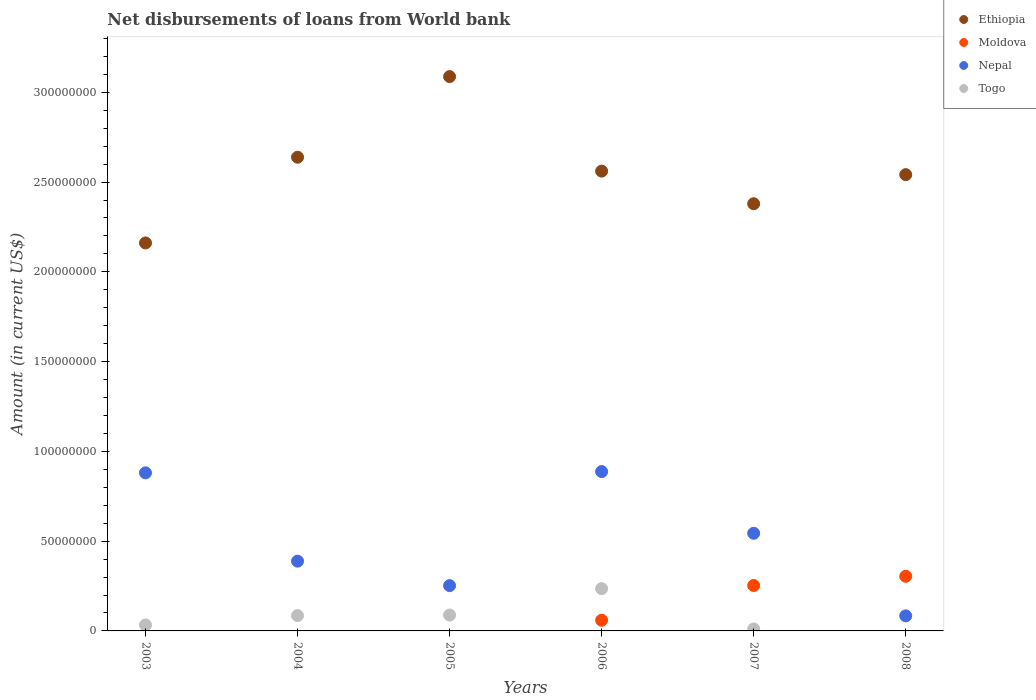How many different coloured dotlines are there?
Your answer should be compact. 4. Is the number of dotlines equal to the number of legend labels?
Provide a succinct answer. No. What is the amount of loan disbursed from World Bank in Nepal in 2004?
Offer a very short reply. 3.89e+07. Across all years, what is the maximum amount of loan disbursed from World Bank in Togo?
Make the answer very short. 2.35e+07. What is the total amount of loan disbursed from World Bank in Moldova in the graph?
Keep it short and to the point. 6.17e+07. What is the difference between the amount of loan disbursed from World Bank in Ethiopia in 2004 and that in 2005?
Provide a short and direct response. -4.49e+07. What is the difference between the amount of loan disbursed from World Bank in Ethiopia in 2006 and the amount of loan disbursed from World Bank in Togo in 2007?
Give a very brief answer. 2.55e+08. What is the average amount of loan disbursed from World Bank in Moldova per year?
Your response must be concise. 1.03e+07. In the year 2006, what is the difference between the amount of loan disbursed from World Bank in Moldova and amount of loan disbursed from World Bank in Togo?
Make the answer very short. -1.76e+07. What is the ratio of the amount of loan disbursed from World Bank in Nepal in 2007 to that in 2008?
Your answer should be very brief. 6.48. What is the difference between the highest and the second highest amount of loan disbursed from World Bank in Moldova?
Your response must be concise. 5.12e+06. What is the difference between the highest and the lowest amount of loan disbursed from World Bank in Nepal?
Provide a short and direct response. 8.04e+07. In how many years, is the amount of loan disbursed from World Bank in Togo greater than the average amount of loan disbursed from World Bank in Togo taken over all years?
Your answer should be compact. 3. Is the sum of the amount of loan disbursed from World Bank in Nepal in 2004 and 2006 greater than the maximum amount of loan disbursed from World Bank in Togo across all years?
Your answer should be compact. Yes. Is it the case that in every year, the sum of the amount of loan disbursed from World Bank in Ethiopia and amount of loan disbursed from World Bank in Moldova  is greater than the amount of loan disbursed from World Bank in Nepal?
Provide a short and direct response. Yes. Is the amount of loan disbursed from World Bank in Ethiopia strictly greater than the amount of loan disbursed from World Bank in Nepal over the years?
Make the answer very short. Yes. Where does the legend appear in the graph?
Your response must be concise. Top right. How many legend labels are there?
Your response must be concise. 4. How are the legend labels stacked?
Make the answer very short. Vertical. What is the title of the graph?
Provide a short and direct response. Net disbursements of loans from World bank. What is the label or title of the X-axis?
Make the answer very short. Years. What is the Amount (in current US$) in Ethiopia in 2003?
Make the answer very short. 2.16e+08. What is the Amount (in current US$) of Nepal in 2003?
Your answer should be very brief. 8.80e+07. What is the Amount (in current US$) in Togo in 2003?
Your response must be concise. 3.32e+06. What is the Amount (in current US$) in Ethiopia in 2004?
Offer a terse response. 2.64e+08. What is the Amount (in current US$) in Moldova in 2004?
Keep it short and to the point. 0. What is the Amount (in current US$) of Nepal in 2004?
Your response must be concise. 3.89e+07. What is the Amount (in current US$) of Togo in 2004?
Offer a terse response. 8.56e+06. What is the Amount (in current US$) in Ethiopia in 2005?
Provide a succinct answer. 3.09e+08. What is the Amount (in current US$) in Nepal in 2005?
Offer a terse response. 2.52e+07. What is the Amount (in current US$) in Togo in 2005?
Make the answer very short. 8.84e+06. What is the Amount (in current US$) of Ethiopia in 2006?
Ensure brevity in your answer.  2.56e+08. What is the Amount (in current US$) of Moldova in 2006?
Your answer should be very brief. 5.95e+06. What is the Amount (in current US$) of Nepal in 2006?
Give a very brief answer. 8.87e+07. What is the Amount (in current US$) in Togo in 2006?
Provide a short and direct response. 2.35e+07. What is the Amount (in current US$) in Ethiopia in 2007?
Make the answer very short. 2.38e+08. What is the Amount (in current US$) in Moldova in 2007?
Provide a short and direct response. 2.53e+07. What is the Amount (in current US$) of Nepal in 2007?
Provide a short and direct response. 5.44e+07. What is the Amount (in current US$) of Togo in 2007?
Your answer should be very brief. 1.07e+06. What is the Amount (in current US$) of Ethiopia in 2008?
Keep it short and to the point. 2.54e+08. What is the Amount (in current US$) of Moldova in 2008?
Give a very brief answer. 3.04e+07. What is the Amount (in current US$) in Nepal in 2008?
Your answer should be compact. 8.39e+06. What is the Amount (in current US$) in Togo in 2008?
Offer a very short reply. 0. Across all years, what is the maximum Amount (in current US$) of Ethiopia?
Your response must be concise. 3.09e+08. Across all years, what is the maximum Amount (in current US$) in Moldova?
Provide a succinct answer. 3.04e+07. Across all years, what is the maximum Amount (in current US$) of Nepal?
Provide a short and direct response. 8.87e+07. Across all years, what is the maximum Amount (in current US$) of Togo?
Give a very brief answer. 2.35e+07. Across all years, what is the minimum Amount (in current US$) of Ethiopia?
Offer a very short reply. 2.16e+08. Across all years, what is the minimum Amount (in current US$) in Nepal?
Your answer should be very brief. 8.39e+06. What is the total Amount (in current US$) of Ethiopia in the graph?
Keep it short and to the point. 1.54e+09. What is the total Amount (in current US$) in Moldova in the graph?
Provide a succinct answer. 6.17e+07. What is the total Amount (in current US$) in Nepal in the graph?
Give a very brief answer. 3.04e+08. What is the total Amount (in current US$) in Togo in the graph?
Your response must be concise. 4.53e+07. What is the difference between the Amount (in current US$) of Ethiopia in 2003 and that in 2004?
Provide a short and direct response. -4.77e+07. What is the difference between the Amount (in current US$) in Nepal in 2003 and that in 2004?
Your answer should be very brief. 4.92e+07. What is the difference between the Amount (in current US$) in Togo in 2003 and that in 2004?
Your answer should be compact. -5.24e+06. What is the difference between the Amount (in current US$) of Ethiopia in 2003 and that in 2005?
Provide a succinct answer. -9.26e+07. What is the difference between the Amount (in current US$) of Nepal in 2003 and that in 2005?
Offer a very short reply. 6.28e+07. What is the difference between the Amount (in current US$) of Togo in 2003 and that in 2005?
Your answer should be very brief. -5.52e+06. What is the difference between the Amount (in current US$) of Ethiopia in 2003 and that in 2006?
Your answer should be very brief. -4.00e+07. What is the difference between the Amount (in current US$) in Nepal in 2003 and that in 2006?
Your answer should be compact. -6.98e+05. What is the difference between the Amount (in current US$) in Togo in 2003 and that in 2006?
Provide a short and direct response. -2.02e+07. What is the difference between the Amount (in current US$) of Ethiopia in 2003 and that in 2007?
Make the answer very short. -2.18e+07. What is the difference between the Amount (in current US$) of Nepal in 2003 and that in 2007?
Your response must be concise. 3.37e+07. What is the difference between the Amount (in current US$) in Togo in 2003 and that in 2007?
Your answer should be compact. 2.25e+06. What is the difference between the Amount (in current US$) of Ethiopia in 2003 and that in 2008?
Make the answer very short. -3.80e+07. What is the difference between the Amount (in current US$) in Nepal in 2003 and that in 2008?
Your response must be concise. 7.97e+07. What is the difference between the Amount (in current US$) of Ethiopia in 2004 and that in 2005?
Your answer should be compact. -4.49e+07. What is the difference between the Amount (in current US$) of Nepal in 2004 and that in 2005?
Give a very brief answer. 1.36e+07. What is the difference between the Amount (in current US$) of Togo in 2004 and that in 2005?
Give a very brief answer. -2.81e+05. What is the difference between the Amount (in current US$) in Ethiopia in 2004 and that in 2006?
Offer a very short reply. 7.74e+06. What is the difference between the Amount (in current US$) of Nepal in 2004 and that in 2006?
Give a very brief answer. -4.99e+07. What is the difference between the Amount (in current US$) in Togo in 2004 and that in 2006?
Your response must be concise. -1.50e+07. What is the difference between the Amount (in current US$) of Ethiopia in 2004 and that in 2007?
Provide a succinct answer. 2.59e+07. What is the difference between the Amount (in current US$) in Nepal in 2004 and that in 2007?
Give a very brief answer. -1.55e+07. What is the difference between the Amount (in current US$) in Togo in 2004 and that in 2007?
Make the answer very short. 7.49e+06. What is the difference between the Amount (in current US$) of Ethiopia in 2004 and that in 2008?
Your response must be concise. 9.70e+06. What is the difference between the Amount (in current US$) of Nepal in 2004 and that in 2008?
Ensure brevity in your answer.  3.05e+07. What is the difference between the Amount (in current US$) in Ethiopia in 2005 and that in 2006?
Provide a short and direct response. 5.26e+07. What is the difference between the Amount (in current US$) in Nepal in 2005 and that in 2006?
Provide a short and direct response. -6.35e+07. What is the difference between the Amount (in current US$) of Togo in 2005 and that in 2006?
Your response must be concise. -1.47e+07. What is the difference between the Amount (in current US$) in Ethiopia in 2005 and that in 2007?
Offer a very short reply. 7.08e+07. What is the difference between the Amount (in current US$) of Nepal in 2005 and that in 2007?
Offer a terse response. -2.92e+07. What is the difference between the Amount (in current US$) of Togo in 2005 and that in 2007?
Provide a short and direct response. 7.77e+06. What is the difference between the Amount (in current US$) of Ethiopia in 2005 and that in 2008?
Offer a terse response. 5.46e+07. What is the difference between the Amount (in current US$) in Nepal in 2005 and that in 2008?
Offer a terse response. 1.68e+07. What is the difference between the Amount (in current US$) of Ethiopia in 2006 and that in 2007?
Offer a terse response. 1.82e+07. What is the difference between the Amount (in current US$) of Moldova in 2006 and that in 2007?
Keep it short and to the point. -1.94e+07. What is the difference between the Amount (in current US$) of Nepal in 2006 and that in 2007?
Provide a short and direct response. 3.44e+07. What is the difference between the Amount (in current US$) in Togo in 2006 and that in 2007?
Offer a terse response. 2.25e+07. What is the difference between the Amount (in current US$) of Ethiopia in 2006 and that in 2008?
Keep it short and to the point. 1.96e+06. What is the difference between the Amount (in current US$) of Moldova in 2006 and that in 2008?
Offer a terse response. -2.45e+07. What is the difference between the Amount (in current US$) in Nepal in 2006 and that in 2008?
Provide a succinct answer. 8.04e+07. What is the difference between the Amount (in current US$) in Ethiopia in 2007 and that in 2008?
Ensure brevity in your answer.  -1.62e+07. What is the difference between the Amount (in current US$) of Moldova in 2007 and that in 2008?
Keep it short and to the point. -5.12e+06. What is the difference between the Amount (in current US$) of Nepal in 2007 and that in 2008?
Offer a terse response. 4.60e+07. What is the difference between the Amount (in current US$) of Ethiopia in 2003 and the Amount (in current US$) of Nepal in 2004?
Your answer should be very brief. 1.77e+08. What is the difference between the Amount (in current US$) of Ethiopia in 2003 and the Amount (in current US$) of Togo in 2004?
Offer a terse response. 2.08e+08. What is the difference between the Amount (in current US$) in Nepal in 2003 and the Amount (in current US$) in Togo in 2004?
Offer a terse response. 7.95e+07. What is the difference between the Amount (in current US$) in Ethiopia in 2003 and the Amount (in current US$) in Nepal in 2005?
Your answer should be very brief. 1.91e+08. What is the difference between the Amount (in current US$) in Ethiopia in 2003 and the Amount (in current US$) in Togo in 2005?
Make the answer very short. 2.07e+08. What is the difference between the Amount (in current US$) of Nepal in 2003 and the Amount (in current US$) of Togo in 2005?
Offer a terse response. 7.92e+07. What is the difference between the Amount (in current US$) of Ethiopia in 2003 and the Amount (in current US$) of Moldova in 2006?
Your answer should be very brief. 2.10e+08. What is the difference between the Amount (in current US$) of Ethiopia in 2003 and the Amount (in current US$) of Nepal in 2006?
Make the answer very short. 1.27e+08. What is the difference between the Amount (in current US$) in Ethiopia in 2003 and the Amount (in current US$) in Togo in 2006?
Provide a succinct answer. 1.93e+08. What is the difference between the Amount (in current US$) in Nepal in 2003 and the Amount (in current US$) in Togo in 2006?
Ensure brevity in your answer.  6.45e+07. What is the difference between the Amount (in current US$) of Ethiopia in 2003 and the Amount (in current US$) of Moldova in 2007?
Your answer should be compact. 1.91e+08. What is the difference between the Amount (in current US$) in Ethiopia in 2003 and the Amount (in current US$) in Nepal in 2007?
Your answer should be compact. 1.62e+08. What is the difference between the Amount (in current US$) in Ethiopia in 2003 and the Amount (in current US$) in Togo in 2007?
Your response must be concise. 2.15e+08. What is the difference between the Amount (in current US$) of Nepal in 2003 and the Amount (in current US$) of Togo in 2007?
Your answer should be very brief. 8.70e+07. What is the difference between the Amount (in current US$) of Ethiopia in 2003 and the Amount (in current US$) of Moldova in 2008?
Ensure brevity in your answer.  1.86e+08. What is the difference between the Amount (in current US$) in Ethiopia in 2003 and the Amount (in current US$) in Nepal in 2008?
Offer a terse response. 2.08e+08. What is the difference between the Amount (in current US$) of Ethiopia in 2004 and the Amount (in current US$) of Nepal in 2005?
Provide a succinct answer. 2.39e+08. What is the difference between the Amount (in current US$) in Ethiopia in 2004 and the Amount (in current US$) in Togo in 2005?
Your response must be concise. 2.55e+08. What is the difference between the Amount (in current US$) of Nepal in 2004 and the Amount (in current US$) of Togo in 2005?
Make the answer very short. 3.00e+07. What is the difference between the Amount (in current US$) of Ethiopia in 2004 and the Amount (in current US$) of Moldova in 2006?
Offer a terse response. 2.58e+08. What is the difference between the Amount (in current US$) of Ethiopia in 2004 and the Amount (in current US$) of Nepal in 2006?
Keep it short and to the point. 1.75e+08. What is the difference between the Amount (in current US$) of Ethiopia in 2004 and the Amount (in current US$) of Togo in 2006?
Ensure brevity in your answer.  2.40e+08. What is the difference between the Amount (in current US$) in Nepal in 2004 and the Amount (in current US$) in Togo in 2006?
Offer a terse response. 1.53e+07. What is the difference between the Amount (in current US$) of Ethiopia in 2004 and the Amount (in current US$) of Moldova in 2007?
Offer a terse response. 2.39e+08. What is the difference between the Amount (in current US$) of Ethiopia in 2004 and the Amount (in current US$) of Nepal in 2007?
Give a very brief answer. 2.09e+08. What is the difference between the Amount (in current US$) of Ethiopia in 2004 and the Amount (in current US$) of Togo in 2007?
Provide a short and direct response. 2.63e+08. What is the difference between the Amount (in current US$) in Nepal in 2004 and the Amount (in current US$) in Togo in 2007?
Provide a short and direct response. 3.78e+07. What is the difference between the Amount (in current US$) of Ethiopia in 2004 and the Amount (in current US$) of Moldova in 2008?
Keep it short and to the point. 2.33e+08. What is the difference between the Amount (in current US$) of Ethiopia in 2004 and the Amount (in current US$) of Nepal in 2008?
Provide a short and direct response. 2.55e+08. What is the difference between the Amount (in current US$) of Ethiopia in 2005 and the Amount (in current US$) of Moldova in 2006?
Offer a terse response. 3.03e+08. What is the difference between the Amount (in current US$) of Ethiopia in 2005 and the Amount (in current US$) of Nepal in 2006?
Give a very brief answer. 2.20e+08. What is the difference between the Amount (in current US$) of Ethiopia in 2005 and the Amount (in current US$) of Togo in 2006?
Ensure brevity in your answer.  2.85e+08. What is the difference between the Amount (in current US$) of Nepal in 2005 and the Amount (in current US$) of Togo in 2006?
Offer a very short reply. 1.69e+06. What is the difference between the Amount (in current US$) of Ethiopia in 2005 and the Amount (in current US$) of Moldova in 2007?
Make the answer very short. 2.83e+08. What is the difference between the Amount (in current US$) in Ethiopia in 2005 and the Amount (in current US$) in Nepal in 2007?
Provide a short and direct response. 2.54e+08. What is the difference between the Amount (in current US$) of Ethiopia in 2005 and the Amount (in current US$) of Togo in 2007?
Ensure brevity in your answer.  3.08e+08. What is the difference between the Amount (in current US$) of Nepal in 2005 and the Amount (in current US$) of Togo in 2007?
Your response must be concise. 2.42e+07. What is the difference between the Amount (in current US$) in Ethiopia in 2005 and the Amount (in current US$) in Moldova in 2008?
Provide a short and direct response. 2.78e+08. What is the difference between the Amount (in current US$) in Ethiopia in 2005 and the Amount (in current US$) in Nepal in 2008?
Ensure brevity in your answer.  3.00e+08. What is the difference between the Amount (in current US$) of Ethiopia in 2006 and the Amount (in current US$) of Moldova in 2007?
Ensure brevity in your answer.  2.31e+08. What is the difference between the Amount (in current US$) of Ethiopia in 2006 and the Amount (in current US$) of Nepal in 2007?
Your answer should be very brief. 2.02e+08. What is the difference between the Amount (in current US$) of Ethiopia in 2006 and the Amount (in current US$) of Togo in 2007?
Provide a short and direct response. 2.55e+08. What is the difference between the Amount (in current US$) of Moldova in 2006 and the Amount (in current US$) of Nepal in 2007?
Give a very brief answer. -4.84e+07. What is the difference between the Amount (in current US$) in Moldova in 2006 and the Amount (in current US$) in Togo in 2007?
Offer a terse response. 4.88e+06. What is the difference between the Amount (in current US$) in Nepal in 2006 and the Amount (in current US$) in Togo in 2007?
Give a very brief answer. 8.77e+07. What is the difference between the Amount (in current US$) in Ethiopia in 2006 and the Amount (in current US$) in Moldova in 2008?
Your answer should be very brief. 2.26e+08. What is the difference between the Amount (in current US$) of Ethiopia in 2006 and the Amount (in current US$) of Nepal in 2008?
Keep it short and to the point. 2.48e+08. What is the difference between the Amount (in current US$) in Moldova in 2006 and the Amount (in current US$) in Nepal in 2008?
Keep it short and to the point. -2.44e+06. What is the difference between the Amount (in current US$) in Ethiopia in 2007 and the Amount (in current US$) in Moldova in 2008?
Provide a short and direct response. 2.07e+08. What is the difference between the Amount (in current US$) in Ethiopia in 2007 and the Amount (in current US$) in Nepal in 2008?
Your answer should be very brief. 2.30e+08. What is the difference between the Amount (in current US$) in Moldova in 2007 and the Amount (in current US$) in Nepal in 2008?
Ensure brevity in your answer.  1.69e+07. What is the average Amount (in current US$) of Ethiopia per year?
Your response must be concise. 2.56e+08. What is the average Amount (in current US$) in Moldova per year?
Keep it short and to the point. 1.03e+07. What is the average Amount (in current US$) of Nepal per year?
Make the answer very short. 5.06e+07. What is the average Amount (in current US$) of Togo per year?
Your response must be concise. 7.56e+06. In the year 2003, what is the difference between the Amount (in current US$) in Ethiopia and Amount (in current US$) in Nepal?
Ensure brevity in your answer.  1.28e+08. In the year 2003, what is the difference between the Amount (in current US$) of Ethiopia and Amount (in current US$) of Togo?
Keep it short and to the point. 2.13e+08. In the year 2003, what is the difference between the Amount (in current US$) of Nepal and Amount (in current US$) of Togo?
Make the answer very short. 8.47e+07. In the year 2004, what is the difference between the Amount (in current US$) of Ethiopia and Amount (in current US$) of Nepal?
Offer a very short reply. 2.25e+08. In the year 2004, what is the difference between the Amount (in current US$) in Ethiopia and Amount (in current US$) in Togo?
Keep it short and to the point. 2.55e+08. In the year 2004, what is the difference between the Amount (in current US$) in Nepal and Amount (in current US$) in Togo?
Give a very brief answer. 3.03e+07. In the year 2005, what is the difference between the Amount (in current US$) of Ethiopia and Amount (in current US$) of Nepal?
Ensure brevity in your answer.  2.84e+08. In the year 2005, what is the difference between the Amount (in current US$) in Ethiopia and Amount (in current US$) in Togo?
Keep it short and to the point. 3.00e+08. In the year 2005, what is the difference between the Amount (in current US$) in Nepal and Amount (in current US$) in Togo?
Ensure brevity in your answer.  1.64e+07. In the year 2006, what is the difference between the Amount (in current US$) in Ethiopia and Amount (in current US$) in Moldova?
Offer a very short reply. 2.50e+08. In the year 2006, what is the difference between the Amount (in current US$) of Ethiopia and Amount (in current US$) of Nepal?
Your answer should be compact. 1.67e+08. In the year 2006, what is the difference between the Amount (in current US$) of Ethiopia and Amount (in current US$) of Togo?
Keep it short and to the point. 2.33e+08. In the year 2006, what is the difference between the Amount (in current US$) in Moldova and Amount (in current US$) in Nepal?
Keep it short and to the point. -8.28e+07. In the year 2006, what is the difference between the Amount (in current US$) in Moldova and Amount (in current US$) in Togo?
Provide a succinct answer. -1.76e+07. In the year 2006, what is the difference between the Amount (in current US$) of Nepal and Amount (in current US$) of Togo?
Give a very brief answer. 6.52e+07. In the year 2007, what is the difference between the Amount (in current US$) in Ethiopia and Amount (in current US$) in Moldova?
Provide a short and direct response. 2.13e+08. In the year 2007, what is the difference between the Amount (in current US$) of Ethiopia and Amount (in current US$) of Nepal?
Make the answer very short. 1.84e+08. In the year 2007, what is the difference between the Amount (in current US$) of Ethiopia and Amount (in current US$) of Togo?
Your answer should be compact. 2.37e+08. In the year 2007, what is the difference between the Amount (in current US$) of Moldova and Amount (in current US$) of Nepal?
Keep it short and to the point. -2.91e+07. In the year 2007, what is the difference between the Amount (in current US$) in Moldova and Amount (in current US$) in Togo?
Your answer should be compact. 2.42e+07. In the year 2007, what is the difference between the Amount (in current US$) in Nepal and Amount (in current US$) in Togo?
Your answer should be very brief. 5.33e+07. In the year 2008, what is the difference between the Amount (in current US$) in Ethiopia and Amount (in current US$) in Moldova?
Provide a short and direct response. 2.24e+08. In the year 2008, what is the difference between the Amount (in current US$) in Ethiopia and Amount (in current US$) in Nepal?
Provide a succinct answer. 2.46e+08. In the year 2008, what is the difference between the Amount (in current US$) of Moldova and Amount (in current US$) of Nepal?
Provide a short and direct response. 2.20e+07. What is the ratio of the Amount (in current US$) of Ethiopia in 2003 to that in 2004?
Offer a terse response. 0.82. What is the ratio of the Amount (in current US$) of Nepal in 2003 to that in 2004?
Your answer should be very brief. 2.27. What is the ratio of the Amount (in current US$) of Togo in 2003 to that in 2004?
Provide a short and direct response. 0.39. What is the ratio of the Amount (in current US$) in Ethiopia in 2003 to that in 2005?
Provide a succinct answer. 0.7. What is the ratio of the Amount (in current US$) in Nepal in 2003 to that in 2005?
Make the answer very short. 3.49. What is the ratio of the Amount (in current US$) of Togo in 2003 to that in 2005?
Make the answer very short. 0.38. What is the ratio of the Amount (in current US$) of Ethiopia in 2003 to that in 2006?
Offer a terse response. 0.84. What is the ratio of the Amount (in current US$) in Togo in 2003 to that in 2006?
Your response must be concise. 0.14. What is the ratio of the Amount (in current US$) in Ethiopia in 2003 to that in 2007?
Make the answer very short. 0.91. What is the ratio of the Amount (in current US$) in Nepal in 2003 to that in 2007?
Provide a short and direct response. 1.62. What is the ratio of the Amount (in current US$) in Togo in 2003 to that in 2007?
Give a very brief answer. 3.09. What is the ratio of the Amount (in current US$) in Ethiopia in 2003 to that in 2008?
Give a very brief answer. 0.85. What is the ratio of the Amount (in current US$) of Nepal in 2003 to that in 2008?
Provide a short and direct response. 10.49. What is the ratio of the Amount (in current US$) of Ethiopia in 2004 to that in 2005?
Your answer should be compact. 0.85. What is the ratio of the Amount (in current US$) in Nepal in 2004 to that in 2005?
Your response must be concise. 1.54. What is the ratio of the Amount (in current US$) in Togo in 2004 to that in 2005?
Provide a short and direct response. 0.97. What is the ratio of the Amount (in current US$) in Ethiopia in 2004 to that in 2006?
Ensure brevity in your answer.  1.03. What is the ratio of the Amount (in current US$) of Nepal in 2004 to that in 2006?
Provide a succinct answer. 0.44. What is the ratio of the Amount (in current US$) in Togo in 2004 to that in 2006?
Provide a succinct answer. 0.36. What is the ratio of the Amount (in current US$) in Ethiopia in 2004 to that in 2007?
Your answer should be very brief. 1.11. What is the ratio of the Amount (in current US$) of Nepal in 2004 to that in 2007?
Provide a short and direct response. 0.71. What is the ratio of the Amount (in current US$) of Togo in 2004 to that in 2007?
Make the answer very short. 7.98. What is the ratio of the Amount (in current US$) of Ethiopia in 2004 to that in 2008?
Offer a terse response. 1.04. What is the ratio of the Amount (in current US$) in Nepal in 2004 to that in 2008?
Your response must be concise. 4.63. What is the ratio of the Amount (in current US$) in Ethiopia in 2005 to that in 2006?
Your answer should be compact. 1.21. What is the ratio of the Amount (in current US$) in Nepal in 2005 to that in 2006?
Offer a very short reply. 0.28. What is the ratio of the Amount (in current US$) of Togo in 2005 to that in 2006?
Ensure brevity in your answer.  0.38. What is the ratio of the Amount (in current US$) in Ethiopia in 2005 to that in 2007?
Provide a short and direct response. 1.3. What is the ratio of the Amount (in current US$) of Nepal in 2005 to that in 2007?
Your answer should be compact. 0.46. What is the ratio of the Amount (in current US$) of Togo in 2005 to that in 2007?
Keep it short and to the point. 8.24. What is the ratio of the Amount (in current US$) in Ethiopia in 2005 to that in 2008?
Keep it short and to the point. 1.21. What is the ratio of the Amount (in current US$) of Nepal in 2005 to that in 2008?
Make the answer very short. 3.01. What is the ratio of the Amount (in current US$) of Ethiopia in 2006 to that in 2007?
Your response must be concise. 1.08. What is the ratio of the Amount (in current US$) in Moldova in 2006 to that in 2007?
Make the answer very short. 0.24. What is the ratio of the Amount (in current US$) in Nepal in 2006 to that in 2007?
Your response must be concise. 1.63. What is the ratio of the Amount (in current US$) in Togo in 2006 to that in 2007?
Give a very brief answer. 21.94. What is the ratio of the Amount (in current US$) in Ethiopia in 2006 to that in 2008?
Your response must be concise. 1.01. What is the ratio of the Amount (in current US$) in Moldova in 2006 to that in 2008?
Offer a very short reply. 0.2. What is the ratio of the Amount (in current US$) in Nepal in 2006 to that in 2008?
Provide a succinct answer. 10.58. What is the ratio of the Amount (in current US$) in Ethiopia in 2007 to that in 2008?
Your response must be concise. 0.94. What is the ratio of the Amount (in current US$) of Moldova in 2007 to that in 2008?
Make the answer very short. 0.83. What is the ratio of the Amount (in current US$) in Nepal in 2007 to that in 2008?
Make the answer very short. 6.48. What is the difference between the highest and the second highest Amount (in current US$) in Ethiopia?
Your answer should be very brief. 4.49e+07. What is the difference between the highest and the second highest Amount (in current US$) in Moldova?
Your response must be concise. 5.12e+06. What is the difference between the highest and the second highest Amount (in current US$) in Nepal?
Offer a very short reply. 6.98e+05. What is the difference between the highest and the second highest Amount (in current US$) in Togo?
Offer a terse response. 1.47e+07. What is the difference between the highest and the lowest Amount (in current US$) in Ethiopia?
Keep it short and to the point. 9.26e+07. What is the difference between the highest and the lowest Amount (in current US$) of Moldova?
Ensure brevity in your answer.  3.04e+07. What is the difference between the highest and the lowest Amount (in current US$) of Nepal?
Ensure brevity in your answer.  8.04e+07. What is the difference between the highest and the lowest Amount (in current US$) in Togo?
Keep it short and to the point. 2.35e+07. 